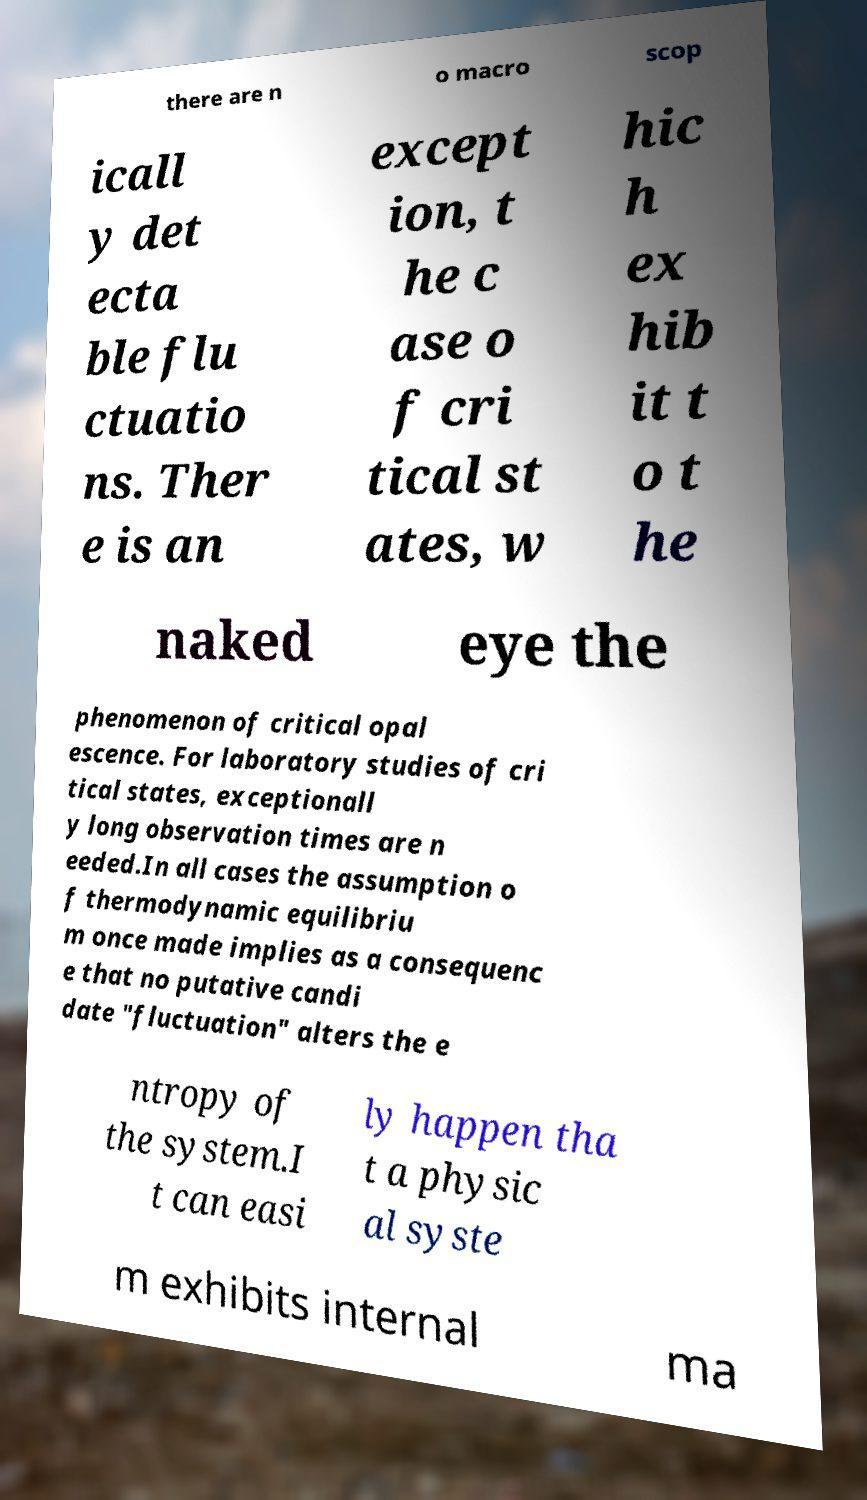Can you read and provide the text displayed in the image?This photo seems to have some interesting text. Can you extract and type it out for me? there are n o macro scop icall y det ecta ble flu ctuatio ns. Ther e is an except ion, t he c ase o f cri tical st ates, w hic h ex hib it t o t he naked eye the phenomenon of critical opal escence. For laboratory studies of cri tical states, exceptionall y long observation times are n eeded.In all cases the assumption o f thermodynamic equilibriu m once made implies as a consequenc e that no putative candi date "fluctuation" alters the e ntropy of the system.I t can easi ly happen tha t a physic al syste m exhibits internal ma 